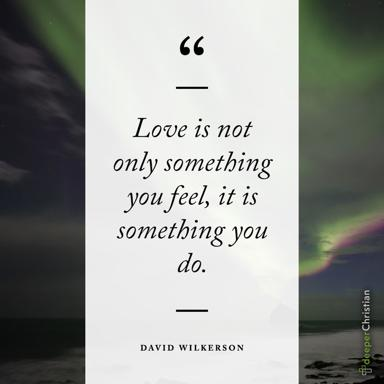How does the background of the image enhance the meaning of the quote? The serene and somewhat dramatic background featuring the rainbow and stormy seas juxtaposes the calm and the challenges, symbolizing that love involves steadiness and effort amidst life's turbulent times. It visually reinforces the message that love’s actions are crucial, especially when the circumstances are tough. 